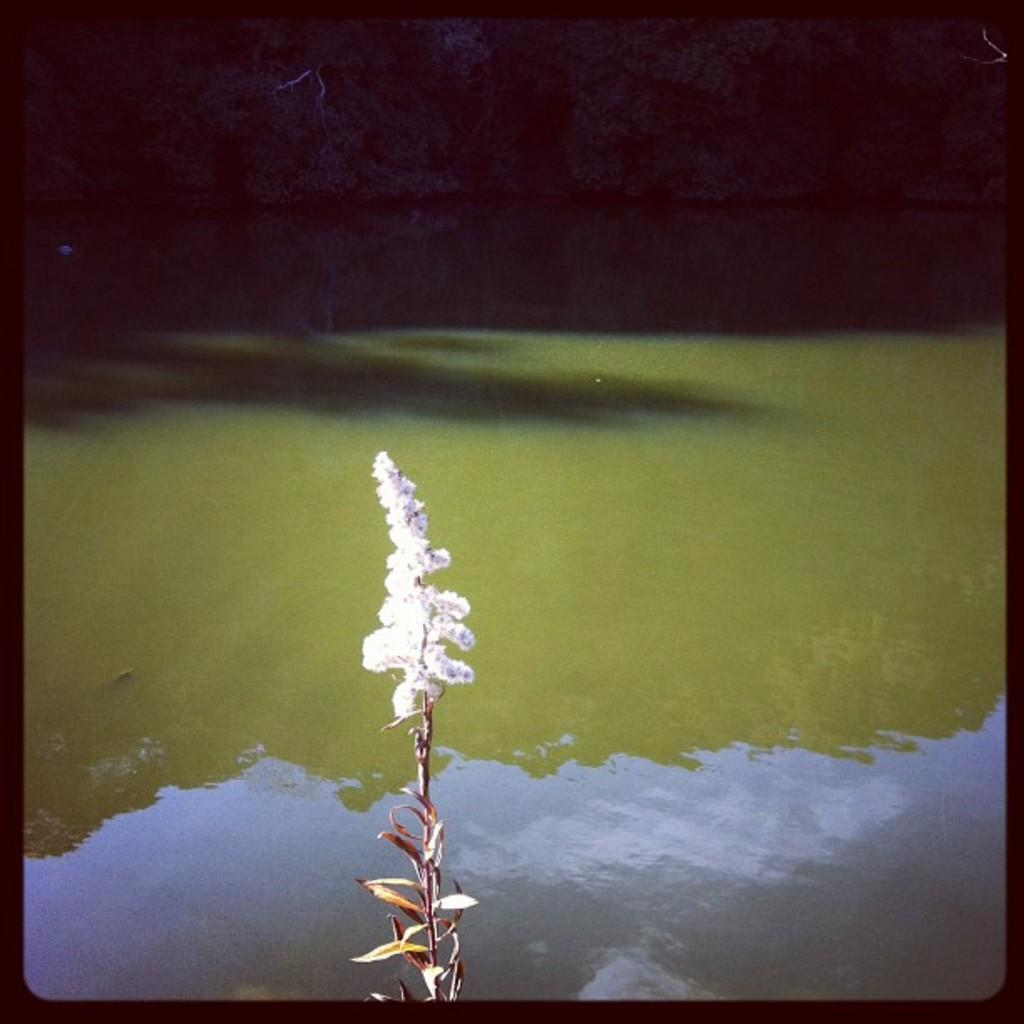What type of plant can be seen in the image? There is a plant with a flower in the image. What other vegetation is present in the image? There are trees in the image. What natural element is visible in the image? Water is visible in the image. What type of face can be seen in the water in the image? There is no face visible in the water in the image. Is the plant with a flower growing in the snow in the image? There is no snow present in the image, and the plant with a flower is not growing in snow. 